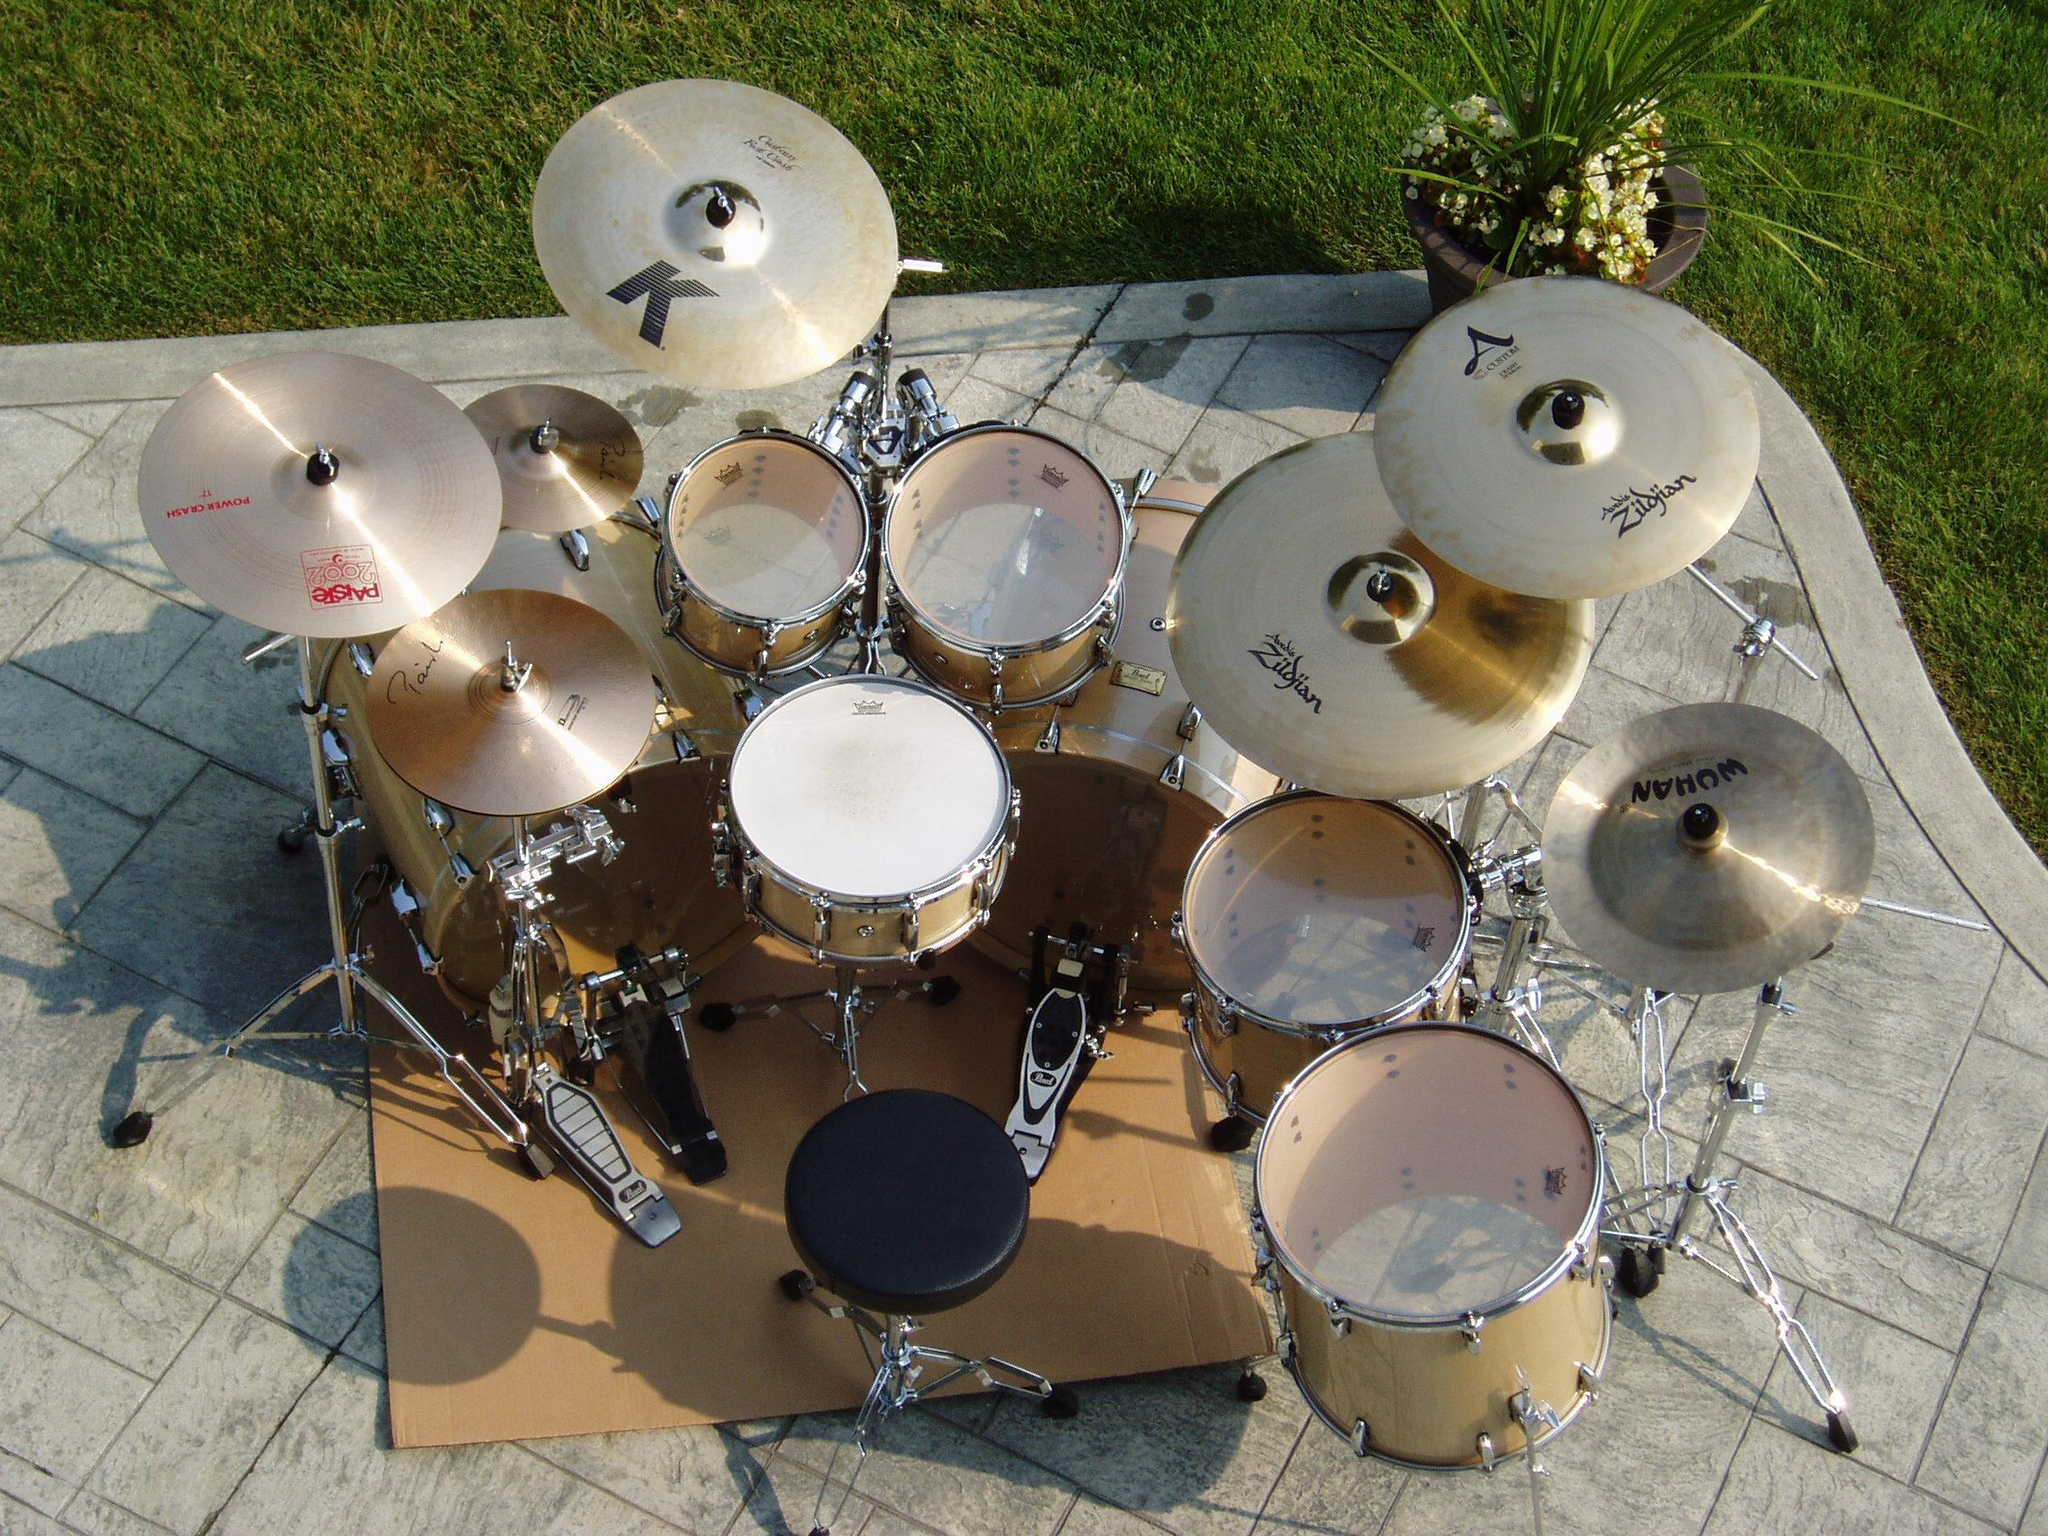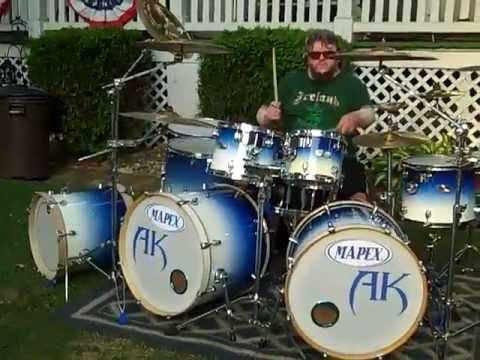The first image is the image on the left, the second image is the image on the right. Examine the images to the left and right. Is the description "One of the images is taken from behind a single drum kit." accurate? Answer yes or no. Yes. 